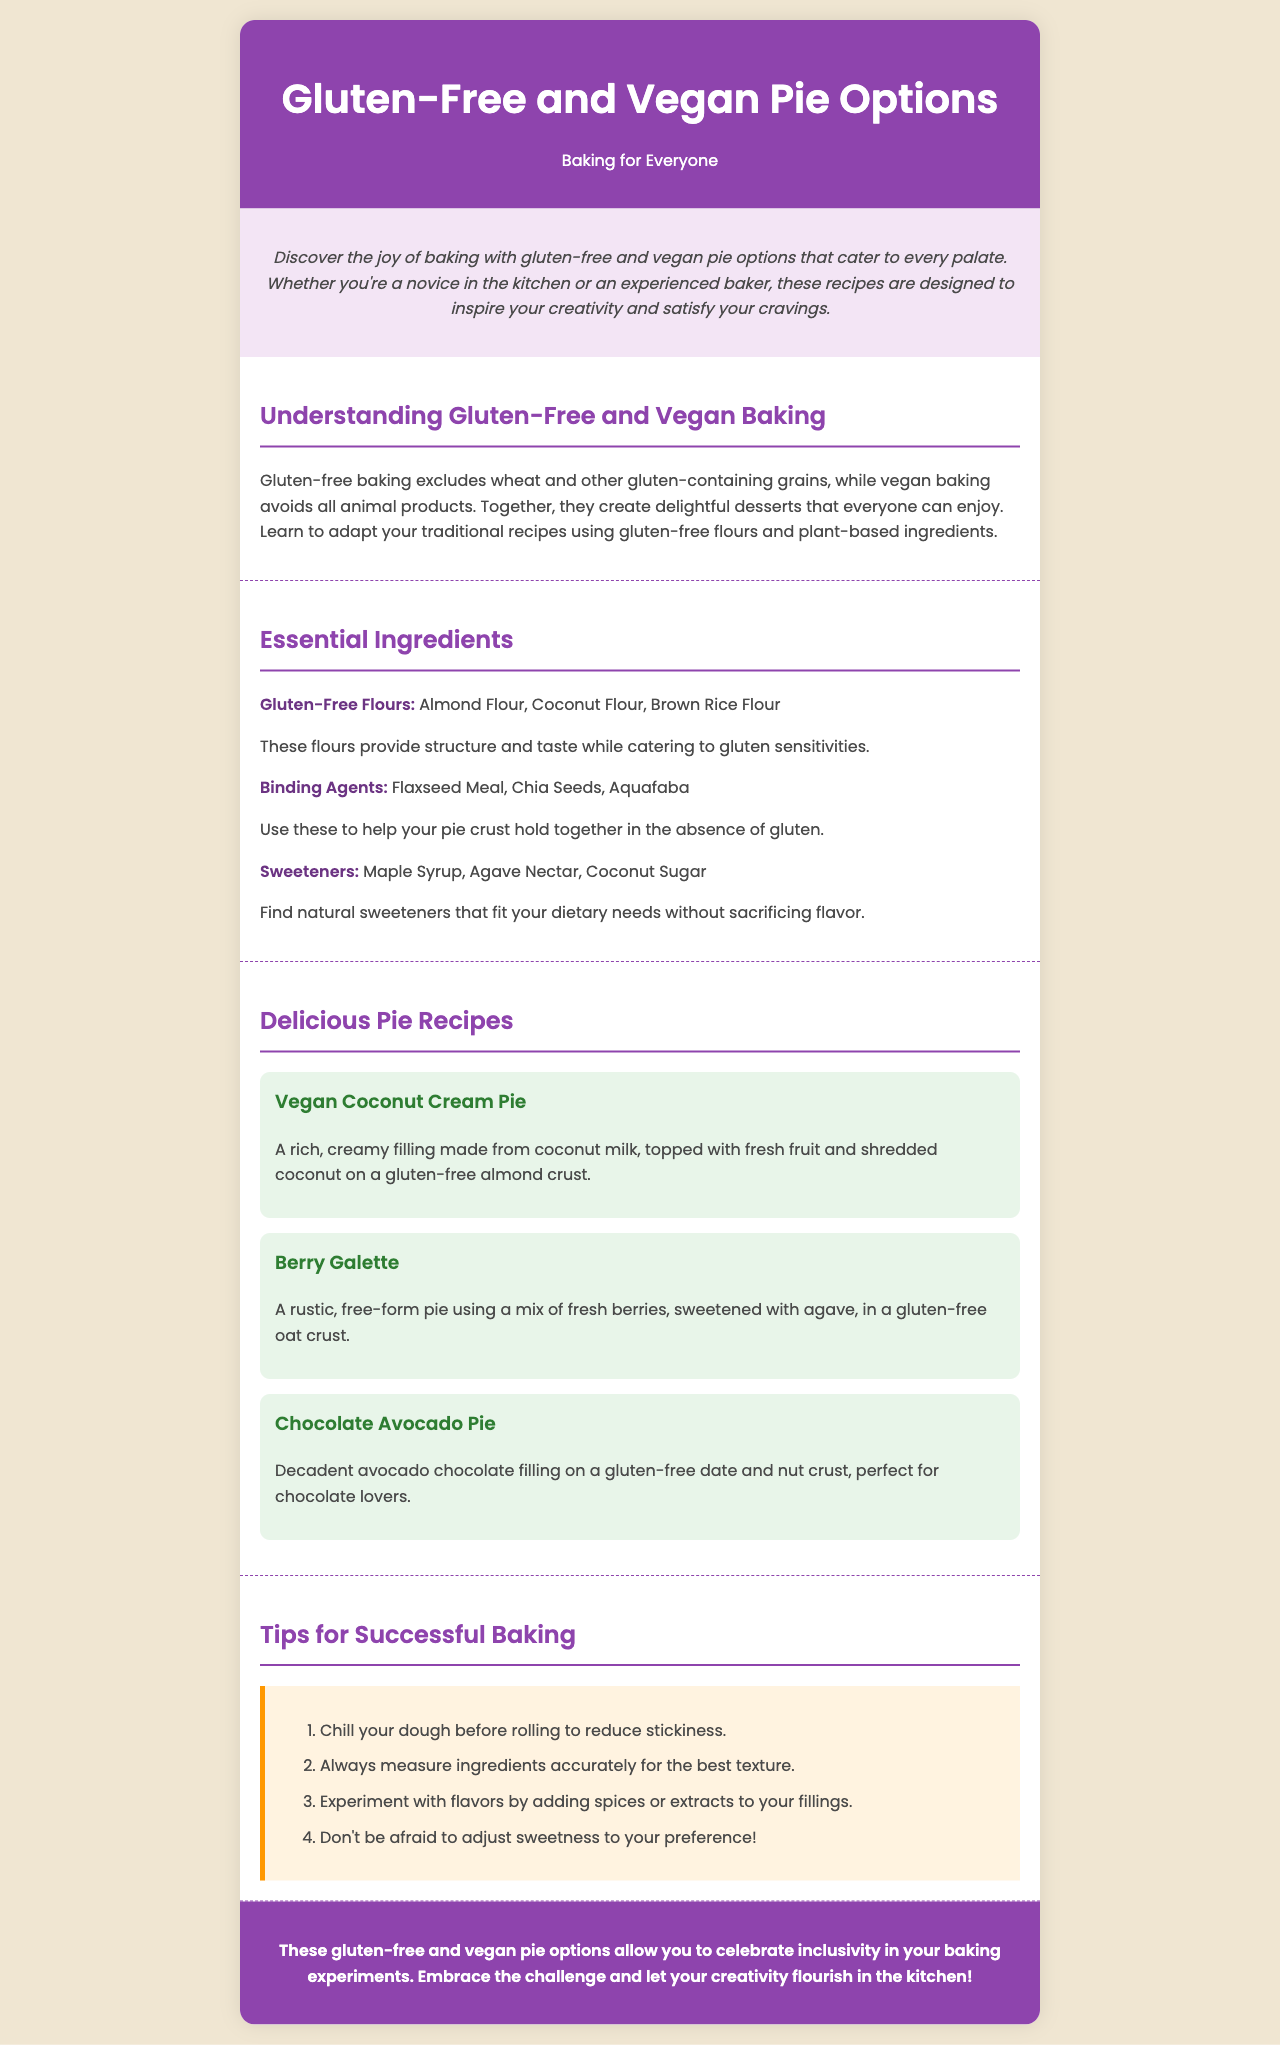What are the examples of gluten-free flours? The document lists three examples of gluten-free flours in the section about essential ingredients.
Answer: Almond Flour, Coconut Flour, Brown Rice Flour What is a key binding agent used in gluten-free baking? The essential ingredients section mentions binding agents. One example is provided.
Answer: Flaxseed Meal How many pie recipes are included in the brochure? The delicious pie recipes section presents three specific recipes.
Answer: 3 What is the filling of the Vegan Coconut Cream Pie made from? The recipe section describes the filling of this pie is made from coconut milk.
Answer: Coconut milk What should you do to reduce stickiness when rolling dough? The tips for successful baking section advises chilling dough before rolling.
Answer: Chill What dietary restrictions do the featured pie options cater to? The brochure’s title and introduction emphasize on gluten-free and vegan options.
Answer: Gluten-free and vegan What type of pie is the Berry Galette? In the recipes section, the Berry Galette is described as a rustic, free-form pie.
Answer: Rustic, free-form What color is the header background? The style element in the document specifies the header color.
Answer: Purple 